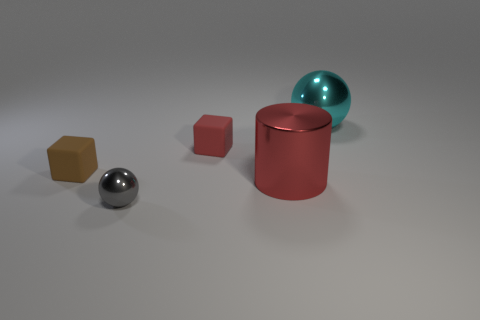Add 3 small cubes. How many objects exist? 8 Subtract all cubes. How many objects are left? 3 Subtract 0 purple cubes. How many objects are left? 5 Subtract all blocks. Subtract all cyan metal spheres. How many objects are left? 2 Add 5 small metallic spheres. How many small metallic spheres are left? 6 Add 5 red rubber cubes. How many red rubber cubes exist? 6 